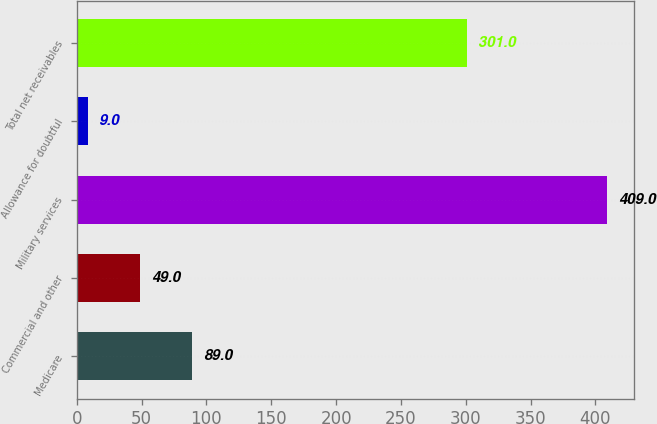<chart> <loc_0><loc_0><loc_500><loc_500><bar_chart><fcel>Medicare<fcel>Commercial and other<fcel>Military services<fcel>Allowance for doubtful<fcel>Total net receivables<nl><fcel>89<fcel>49<fcel>409<fcel>9<fcel>301<nl></chart> 